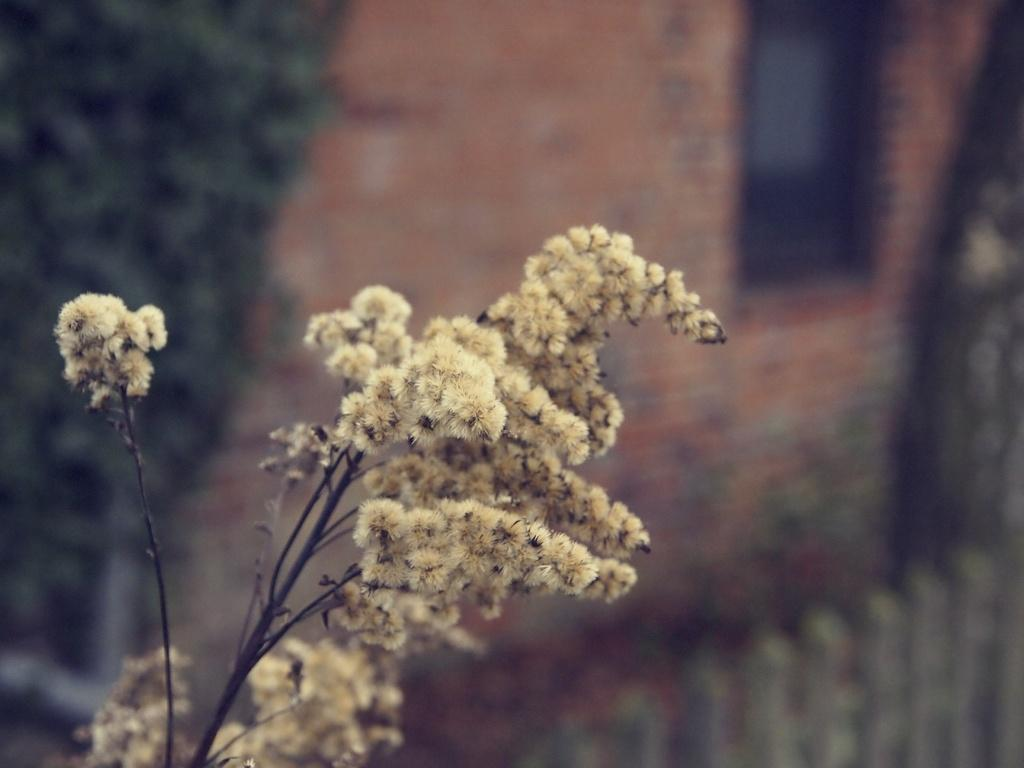What type of plant is present in the image? There are flowers on the plant in the image. What can be seen in the background of the image? There is a tree, fencing, and a building visible in the background of the image. Where is the window located in the image? There is a window in the top right corner of the image. What type of ring can be seen on the tree in the image? There is no ring present on the tree in the image. What kind of net is used to catch the flowers in the image? There is no net visible in the image, and flowers do not require catching. 